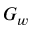<formula> <loc_0><loc_0><loc_500><loc_500>G _ { w }</formula> 